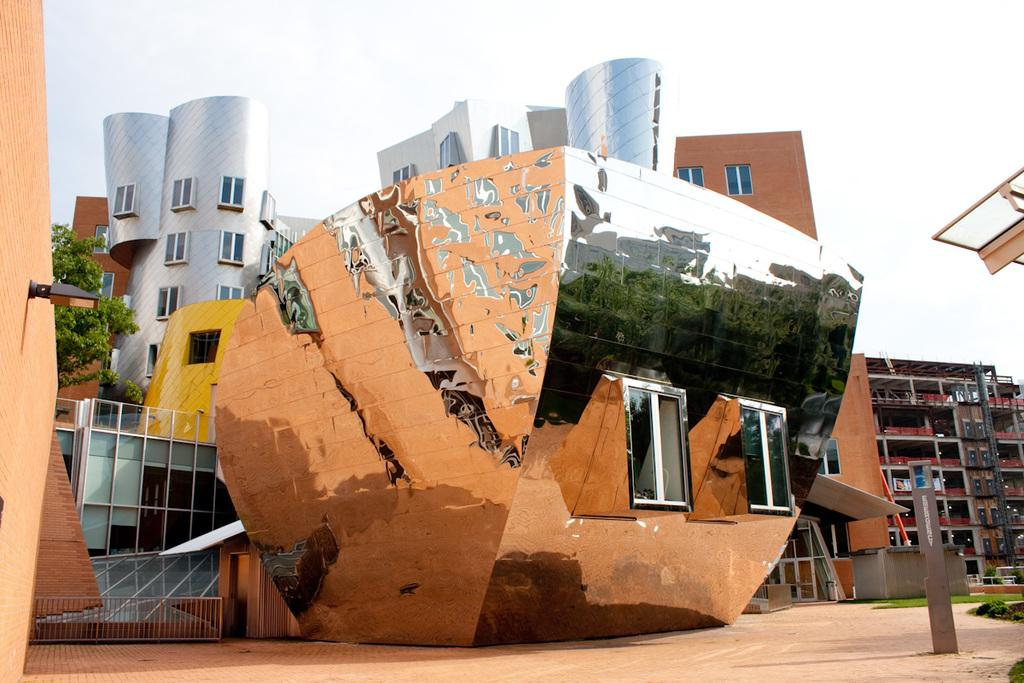What type of structures can be seen in the image? There are buildings in the image. Can you describe any specific features of the buildings? Unfortunately, the provided facts do not mention any specific features of the buildings. What is hanging on a wall in the image? There is a lamp hanging on a wall in the image. What can be seen in the background of the image? The sky is visible in the background of the image. What type of sand can be seen in the image? There is no sand present in the image. Can you tell me how many guides are visible in the image? There is no mention of guides in the provided facts, so it cannot be determined from the image. 